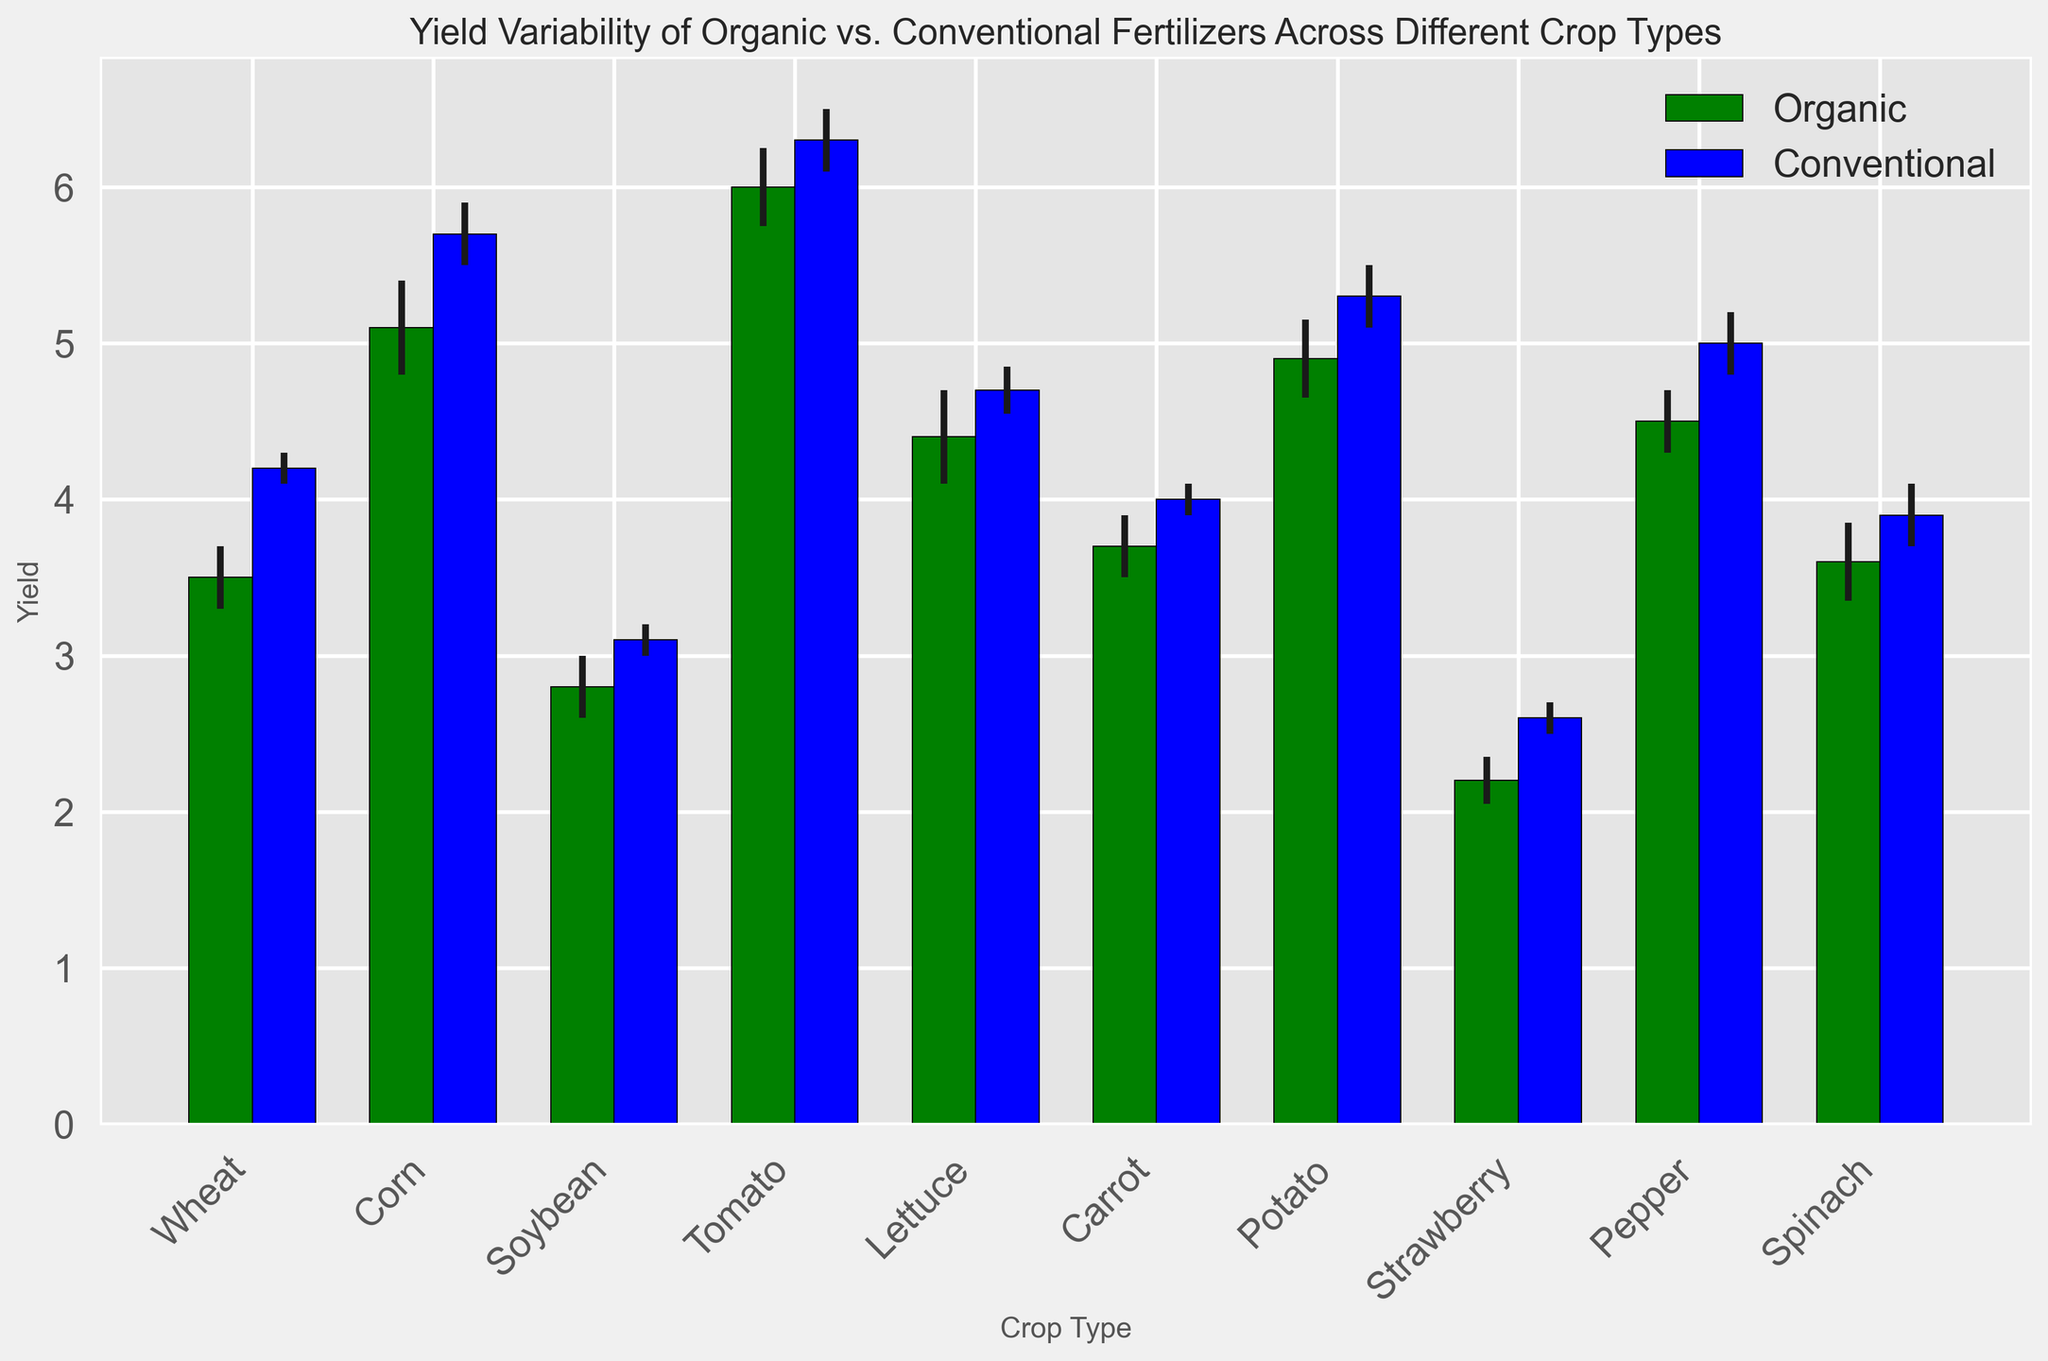Which crop has the highest yield with organic fertilizer? The tallest green bar represents the crop with the highest yield under organic fertilizer. Comparing the heights, Tomato has the highest yield among all crops when using organic fertilizer.
Answer: Tomato Which crop shows the largest yield difference between organic and conventional fertilizers? Measure the difference in height between the paired green and blue bars for each crop, then find the largest difference. The largest difference is seen with Corn.
Answer: Corn On average, which type of fertilizer provides a higher yield across all crops? Calculate the average yield of both organic and conventional fertilizers by summing their yields and dividing by the number of crops. The average yield for Organic is (3.5+5.1+2.8+6.0+4.4+3.7+4.9+2.2+4.5+3.6)/10 = 4.07, and for Conventional is (4.2+5.7+3.1+6.3+4.7+4.0+5.3+2.6+5.0+3.9)/10 = 4.58. Conventional fertilizers provide a higher yield on average.
Answer: Conventional For which crop does the yield of organic fertilizer fall within the error range of the yield of conventional fertilizer? Look for green bars (organic) whose error bars extend within the range of the blue bars (conventional) at either edge. Lettuce's organic yield falls within the error range of its conventional yield.
Answer: Lettuce Which crop exhibits the smallest yield error for organic fertilizer? Identify the green bar with the smallest error bar length. Wheat has the smallest error bar for organic fertilizer, indicating the smallest yield error.
Answer: Wheat 